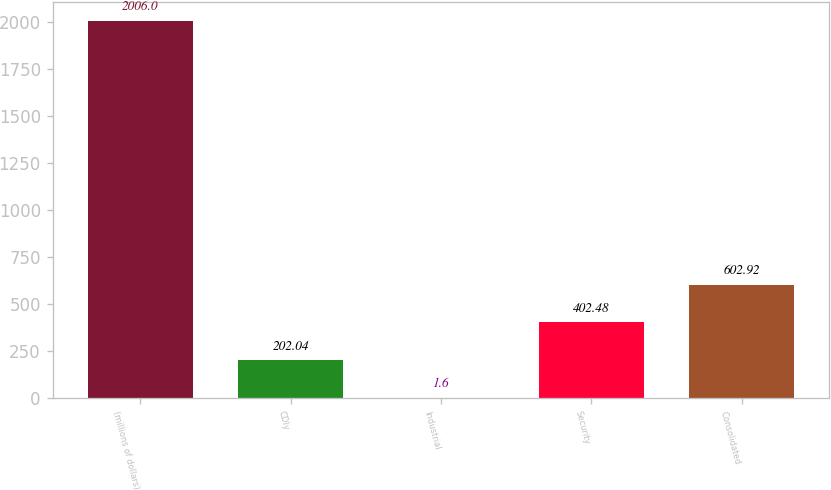Convert chart. <chart><loc_0><loc_0><loc_500><loc_500><bar_chart><fcel>(millions of dollars)<fcel>CDIy<fcel>Industrial<fcel>Security<fcel>Consolidated<nl><fcel>2006<fcel>202.04<fcel>1.6<fcel>402.48<fcel>602.92<nl></chart> 